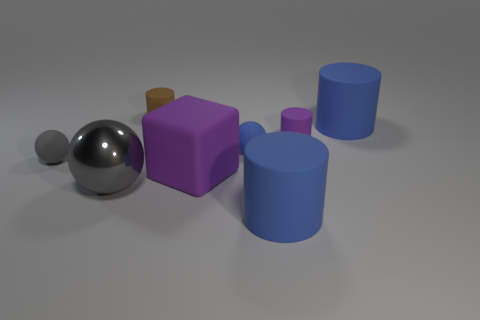Is the number of tiny cyan matte balls greater than the number of cylinders?
Offer a terse response. No. What material is the tiny brown object?
Ensure brevity in your answer.  Rubber. There is a tiny cylinder that is to the right of the brown matte object; what number of big things are on the left side of it?
Keep it short and to the point. 3. Is the color of the big metal ball the same as the large object behind the small purple object?
Provide a short and direct response. No. What color is the other rubber sphere that is the same size as the blue rubber ball?
Make the answer very short. Gray. Is there another shiny object of the same shape as the tiny gray object?
Your response must be concise. Yes. Is the number of gray things less than the number of rubber things?
Give a very brief answer. Yes. What is the color of the tiny matte cylinder that is right of the big block?
Keep it short and to the point. Purple. There is a blue object to the right of the blue cylinder that is in front of the tiny gray matte object; what shape is it?
Keep it short and to the point. Cylinder. Is the material of the blue ball the same as the tiny object in front of the tiny blue rubber ball?
Make the answer very short. Yes. 